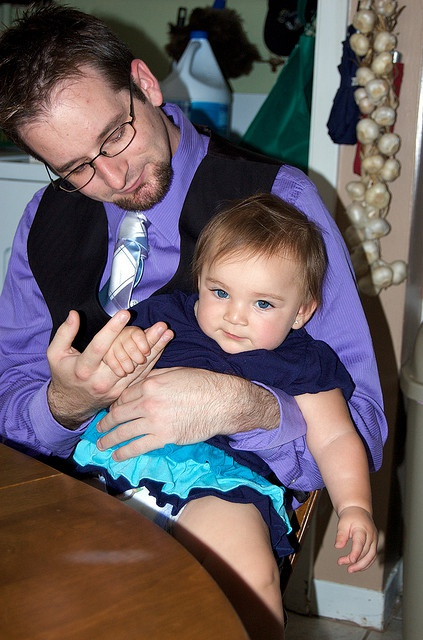Describe the objects in this image and their specific colors. I can see people in black, lightpink, blue, and violet tones, people in black, tan, and navy tones, dining table in black, maroon, and brown tones, bottle in black, gray, and navy tones, and tie in black, white, gray, and darkgray tones in this image. 